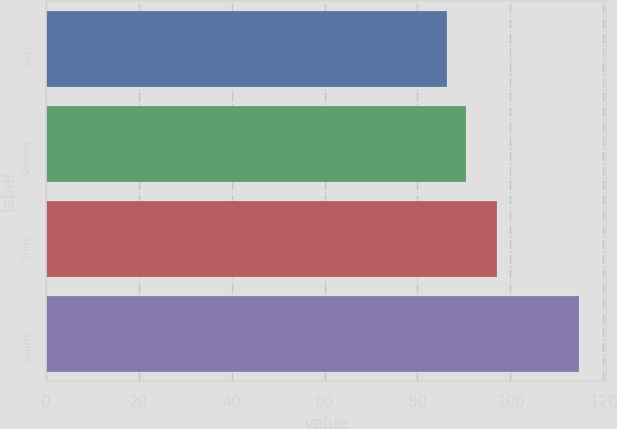<chart> <loc_0><loc_0><loc_500><loc_500><bar_chart><fcel>First<fcel>Second<fcel>Third<fcel>Fourth<nl><fcel>86.31<fcel>90.34<fcel>97.12<fcel>114.75<nl></chart> 